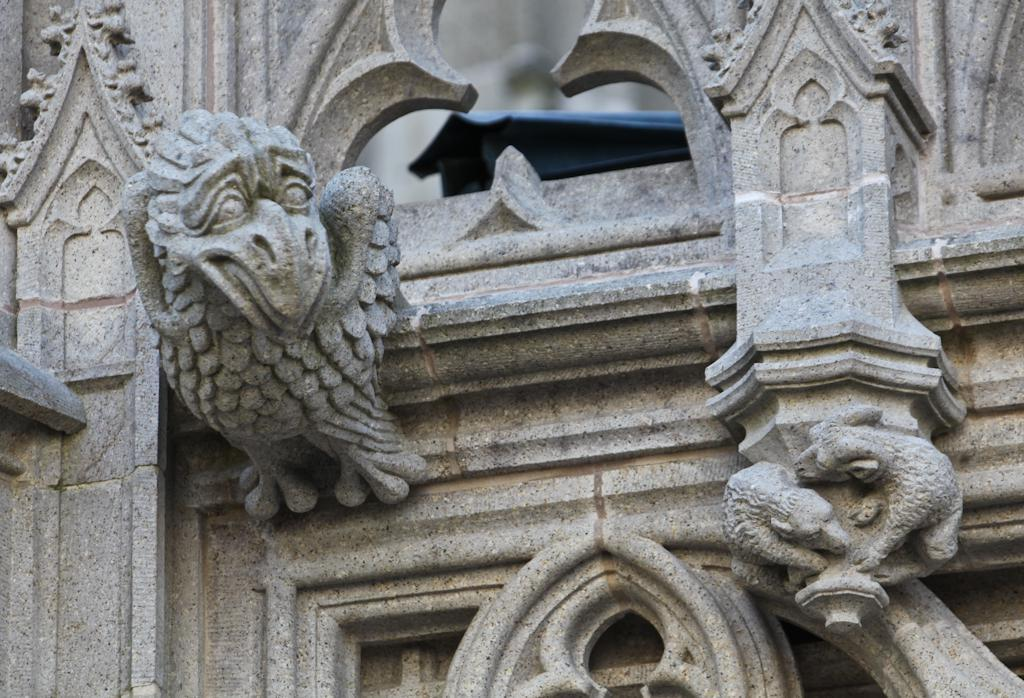What type of artwork is on the wall in the image? There are sculptures on the wall in the image. Can you describe the object at the back of the image? There is a black color object at the back of the image. What month is depicted in the sculptures on the wall? The sculptures on the wall do not depict a month; they are sculptures, not representations of time. Are there any bananas hanging from the ceiling in the image? There are no bananas present in the image. 